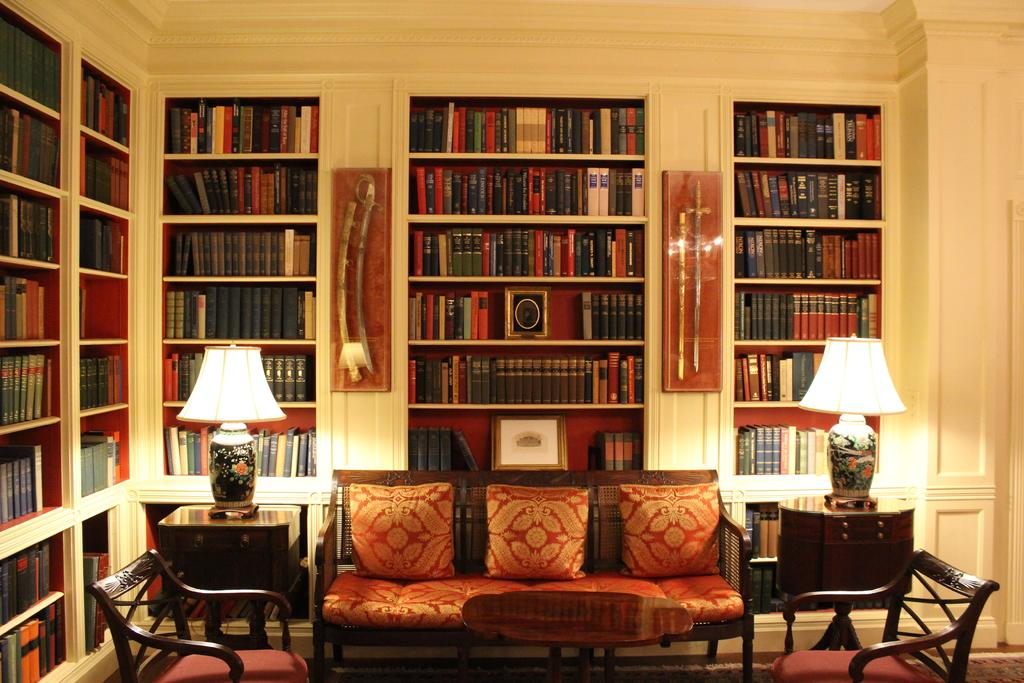What type of space is depicted in the image? There is a room in the image. What furniture is present in the room? There is a sofa, a lamp, a chair, and a cupboard in the room. What can be found inside the cupboard? There are books inside the cupboard. What type of science experiments are being conducted in the room? There is no indication of any science experiments being conducted in the room; the image only shows a room with furniture and a cupboard containing books. 